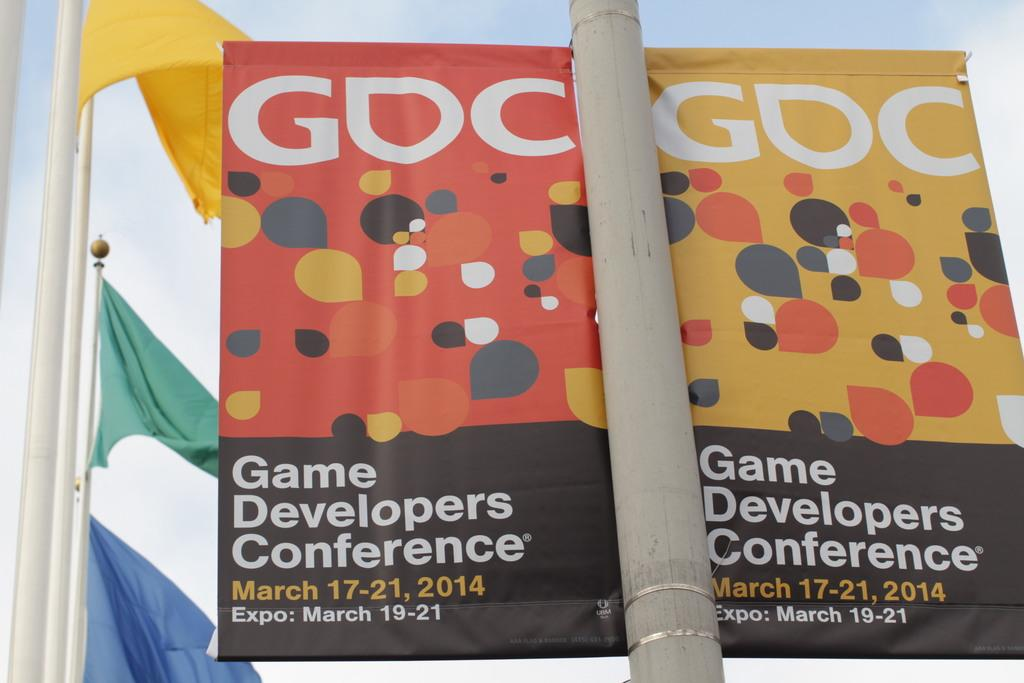Provide a one-sentence caption for the provided image. A double sided sign on a pole for the Game Developers Conference. 